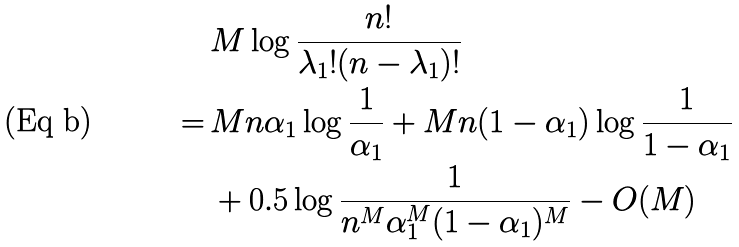<formula> <loc_0><loc_0><loc_500><loc_500>& M \log \frac { n ! } { \lambda _ { 1 } ! ( n - \lambda _ { 1 } ) ! } \\ \, = \, & M n \alpha _ { 1 } \log \frac { 1 } { \alpha _ { 1 } } + M n ( 1 - \alpha _ { 1 } ) \log \frac { 1 } { 1 - \alpha _ { 1 } } \\ & + 0 . 5 \log \frac { 1 } { n ^ { M } \alpha _ { 1 } ^ { M } ( 1 - \alpha _ { 1 } ) ^ { M } } - O ( M )</formula> 